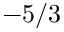Convert formula to latex. <formula><loc_0><loc_0><loc_500><loc_500>- 5 / 3</formula> 